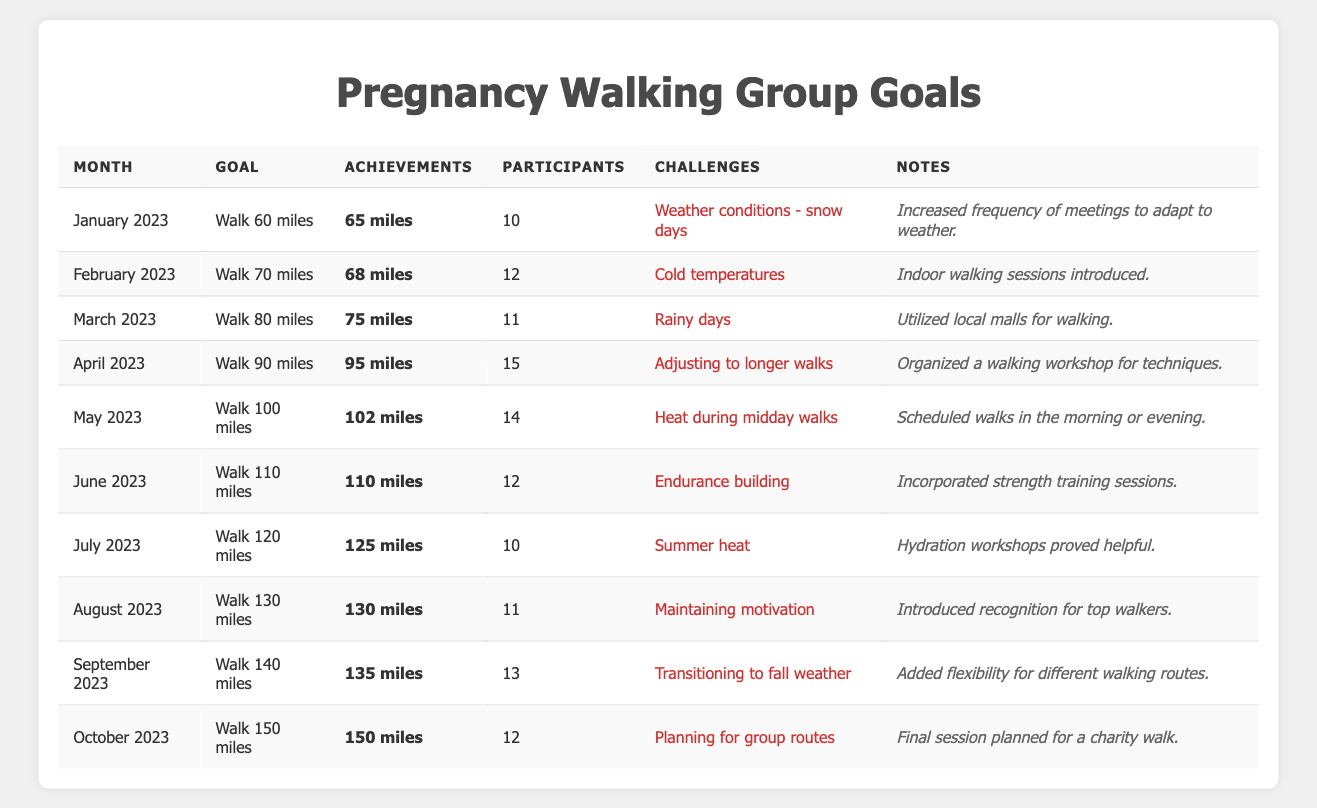What was the goal for March 2023? The table lists the goal for each month under the "Goal" column. For March 2023, the goal was "Walk 80 miles."
Answer: Walk 80 miles How many members participated in April 2023? To find this, we look at the "Participants" column for April 2023, which shows that 15 members participated.
Answer: 15 What was the total number of miles achieved from January to March 2023? We need to sum the achievements from January (65), February (68), and March (75). Adding these gives 65 + 68 + 75 = 208 miles.
Answer: 208 miles Did the walking group achieve their goal in June 2023? In June, the goal was to walk 110 miles, and they achieved exactly 110 miles, indicating they reached their goal.
Answer: Yes What was the average distance achieved by the group during the first half of the year (January to June 2023)? We find the achievements for these months: January (65), February (68), March (75), April (95), May (102), and June (110). The sum is 65 + 68 + 75 + 95 + 102 + 110 = 515 miles. There are 6 months, so the average is 515 / 6 = approximately 85.83 miles.
Answer: Approximately 85.83 miles What challenges did the group face in July 2023? The challenges for July 2023 are noted in the table under the "Challenges" column, which states: "Summer heat."
Answer: Summer heat In which month did the group have the highest number of participants? By checking the "Participants" column, April 2023 had the highest number of participants with 15 members.
Answer: April 2023 Was there a notable change in the number of achievements from May to June 2023? In May, the achievements were 102 miles, while in June, they achieved 110 miles. That shows an increase of 8 miles from May to June.
Answer: Yes, an increase of 8 miles What is the total number of challenges listed from January to October 2023? To find this, we count the number of challenges listed for each month from January to October. There are 10 entries, so the total number of challenges is 10.
Answer: 10 What was the goal for October 2023, and how did it compare to the achievements? The goal for October 2023 was to walk 150 miles, and they achieved exactly 150 miles, meaning they met their goal.
Answer: Achieved goal; goal was 150 miles 